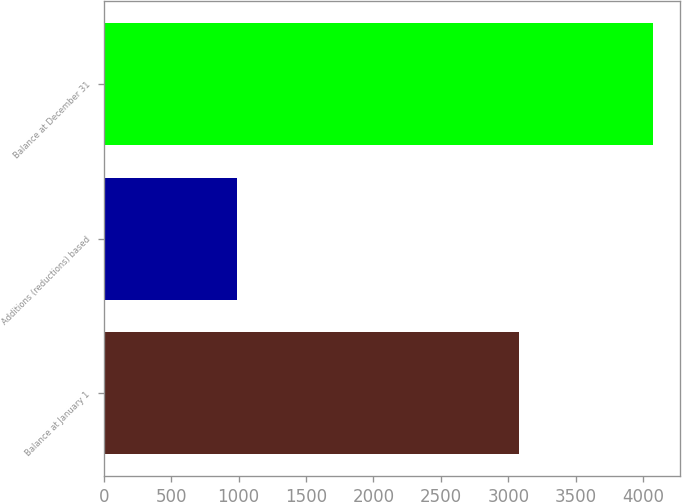Convert chart. <chart><loc_0><loc_0><loc_500><loc_500><bar_chart><fcel>Balance at January 1<fcel>Additions (reductions) based<fcel>Balance at December 31<nl><fcel>3079<fcel>992<fcel>4071<nl></chart> 